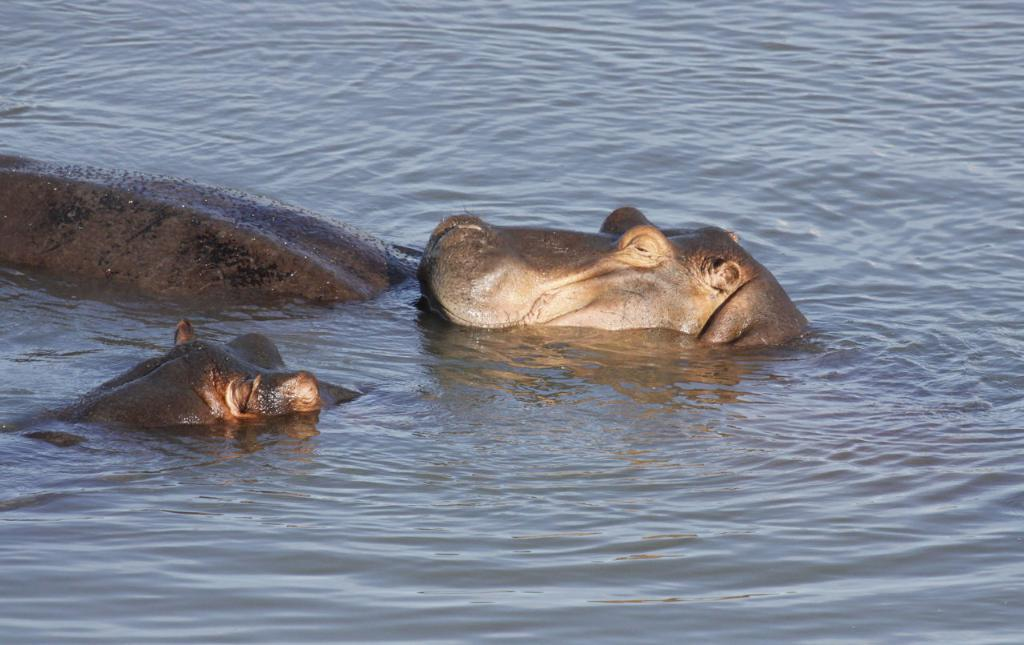What animals are present in the image? There are two hippopotamuses in the image. Where are the hippopotamuses located? The hippopotamuses are in the water. What type of balloon can be seen floating above the hippopotamuses in the image? There is no balloon present in the image; it only features two hippopotamuses in the water. 